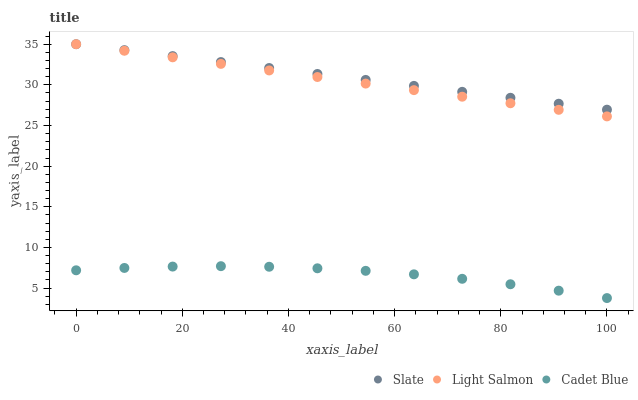Does Cadet Blue have the minimum area under the curve?
Answer yes or no. Yes. Does Slate have the maximum area under the curve?
Answer yes or no. Yes. Does Light Salmon have the minimum area under the curve?
Answer yes or no. No. Does Light Salmon have the maximum area under the curve?
Answer yes or no. No. Is Light Salmon the smoothest?
Answer yes or no. Yes. Is Cadet Blue the roughest?
Answer yes or no. Yes. Is Cadet Blue the smoothest?
Answer yes or no. No. Is Light Salmon the roughest?
Answer yes or no. No. Does Cadet Blue have the lowest value?
Answer yes or no. Yes. Does Light Salmon have the lowest value?
Answer yes or no. No. Does Light Salmon have the highest value?
Answer yes or no. Yes. Does Cadet Blue have the highest value?
Answer yes or no. No. Is Cadet Blue less than Slate?
Answer yes or no. Yes. Is Slate greater than Cadet Blue?
Answer yes or no. Yes. Does Light Salmon intersect Slate?
Answer yes or no. Yes. Is Light Salmon less than Slate?
Answer yes or no. No. Is Light Salmon greater than Slate?
Answer yes or no. No. Does Cadet Blue intersect Slate?
Answer yes or no. No. 